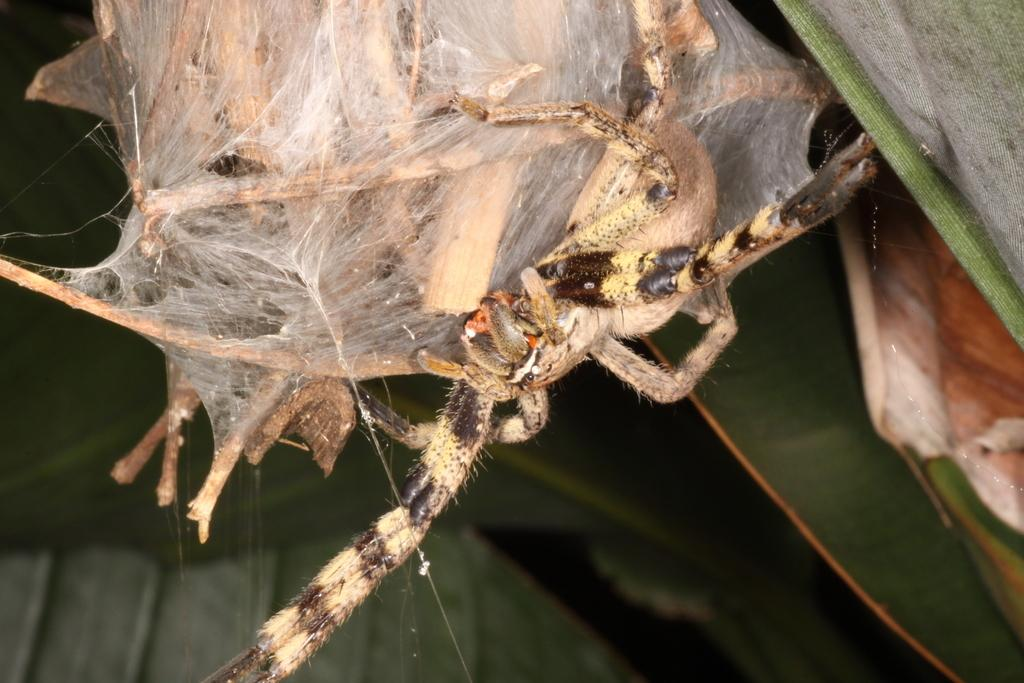What type of creature can be seen in the image? There is a bug in the image. What type of vegetation is present in the image? There is a plant in the image. What type of door can be seen in the image? There is no door present in the image; it only features a bug and a plant. What action is the bug performing in the image? The provided facts do not specify any action being performed by the bug in the image. 